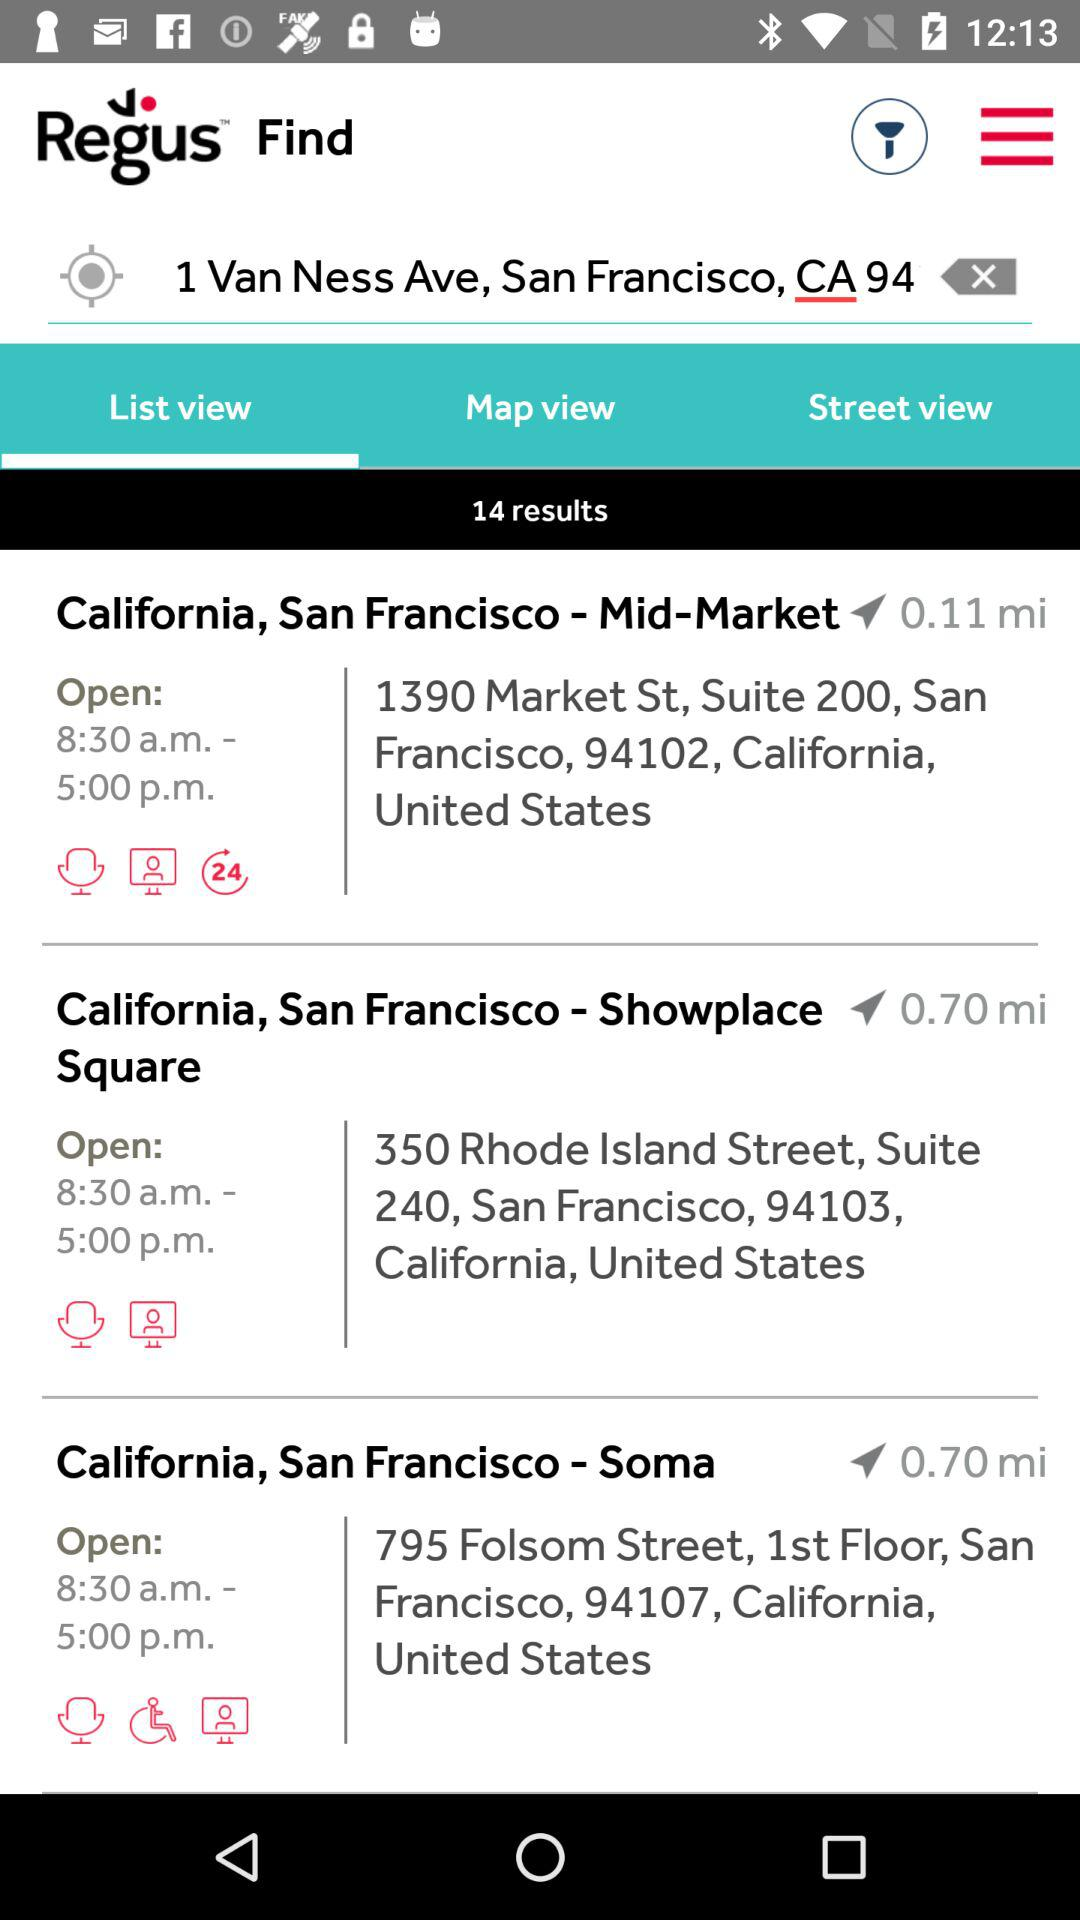How many results are there for the search?
Answer the question using a single word or phrase. 14 